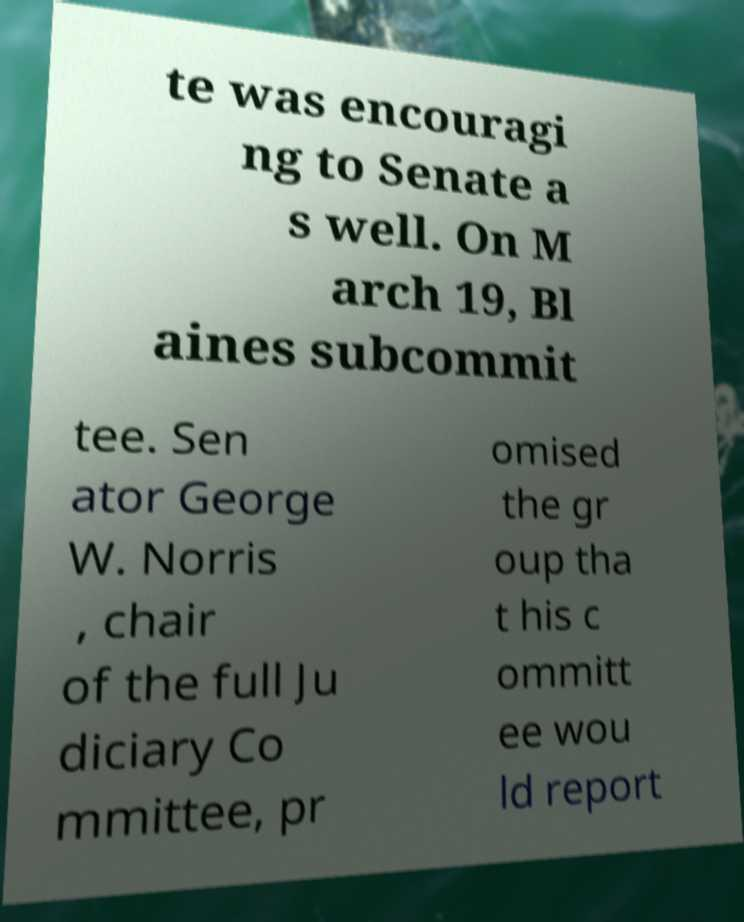Could you extract and type out the text from this image? te was encouragi ng to Senate a s well. On M arch 19, Bl aines subcommit tee. Sen ator George W. Norris , chair of the full Ju diciary Co mmittee, pr omised the gr oup tha t his c ommitt ee wou ld report 